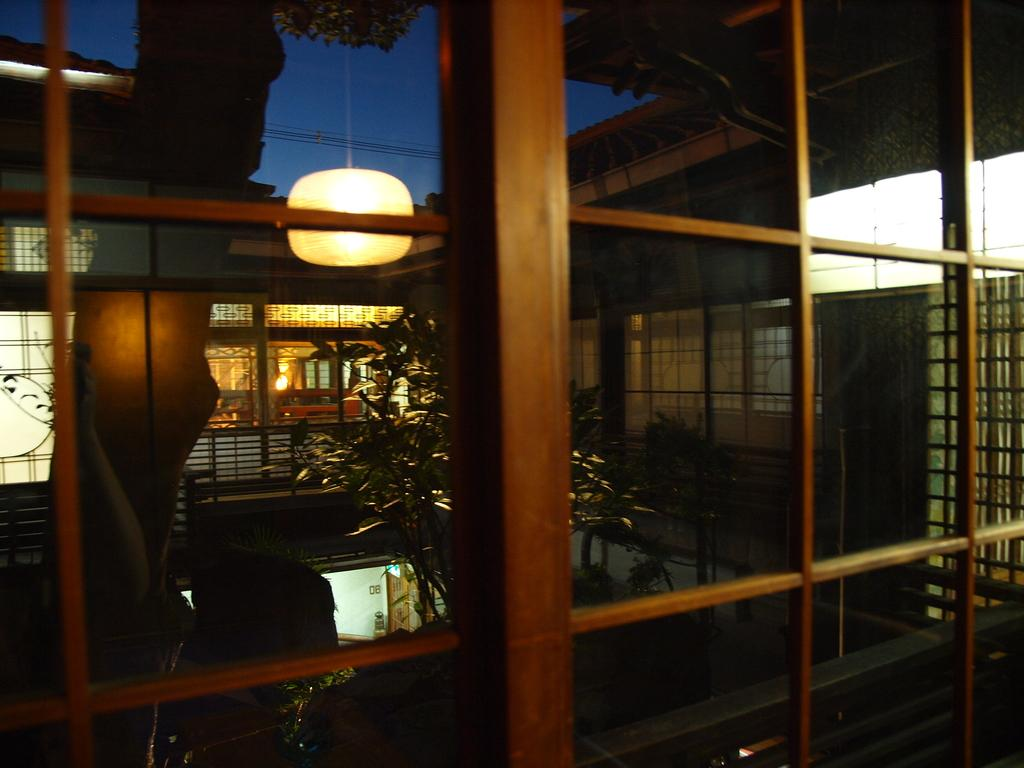What type of reflection can be seen in the image? There are reflections of a window, a plant, and a screen in the image. What else is visible in the image besides reflections? There is a reflection of light in the image, and the sky is visible at the top of the image. How is the image described in terms of lighting? The image is described as being a little dark. What is the size of the yam in the image? There is no yam present in the image; it only contains reflections and the sky. How far away is the plant from the window in the image? The image only shows reflections, so it is not possible to determine the distance between the plant and the window. 